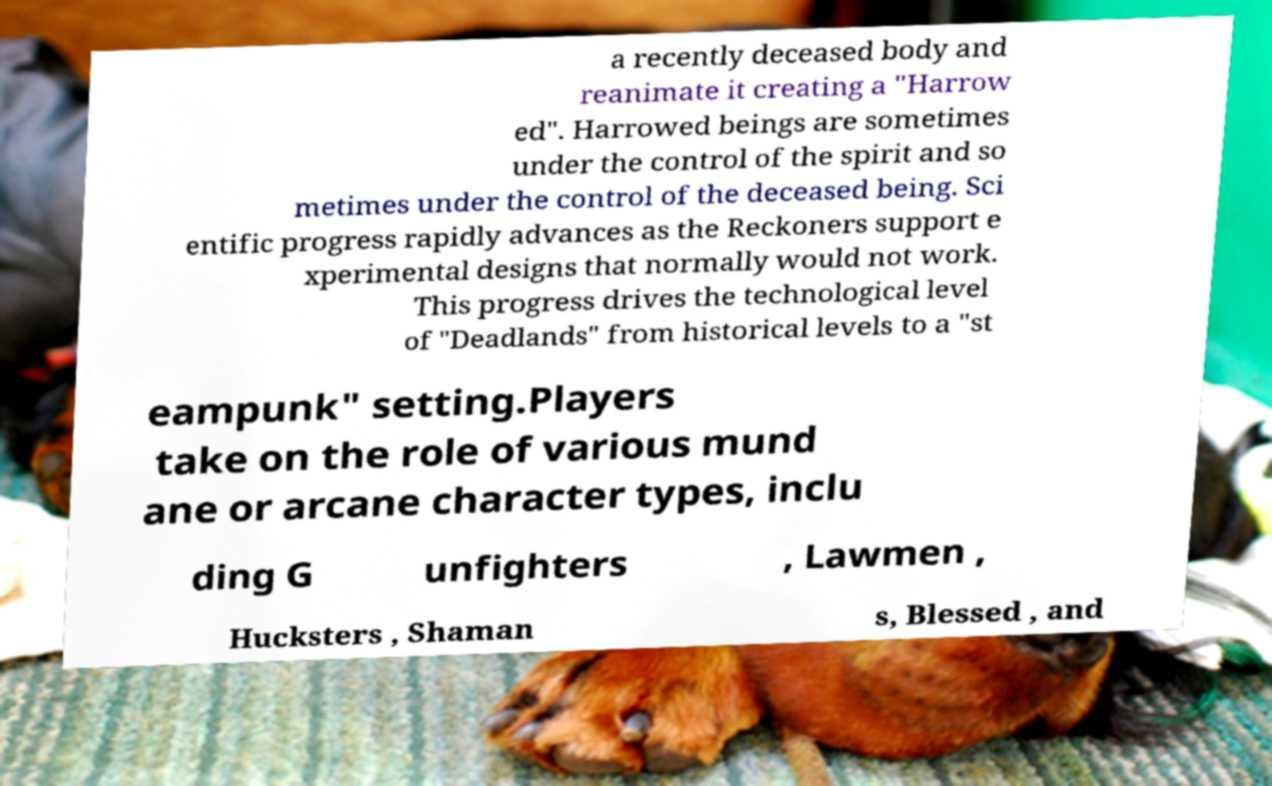Could you extract and type out the text from this image? a recently deceased body and reanimate it creating a "Harrow ed". Harrowed beings are sometimes under the control of the spirit and so metimes under the control of the deceased being. Sci entific progress rapidly advances as the Reckoners support e xperimental designs that normally would not work. This progress drives the technological level of "Deadlands" from historical levels to a "st eampunk" setting.Players take on the role of various mund ane or arcane character types, inclu ding G unfighters , Lawmen , Hucksters , Shaman s, Blessed , and 